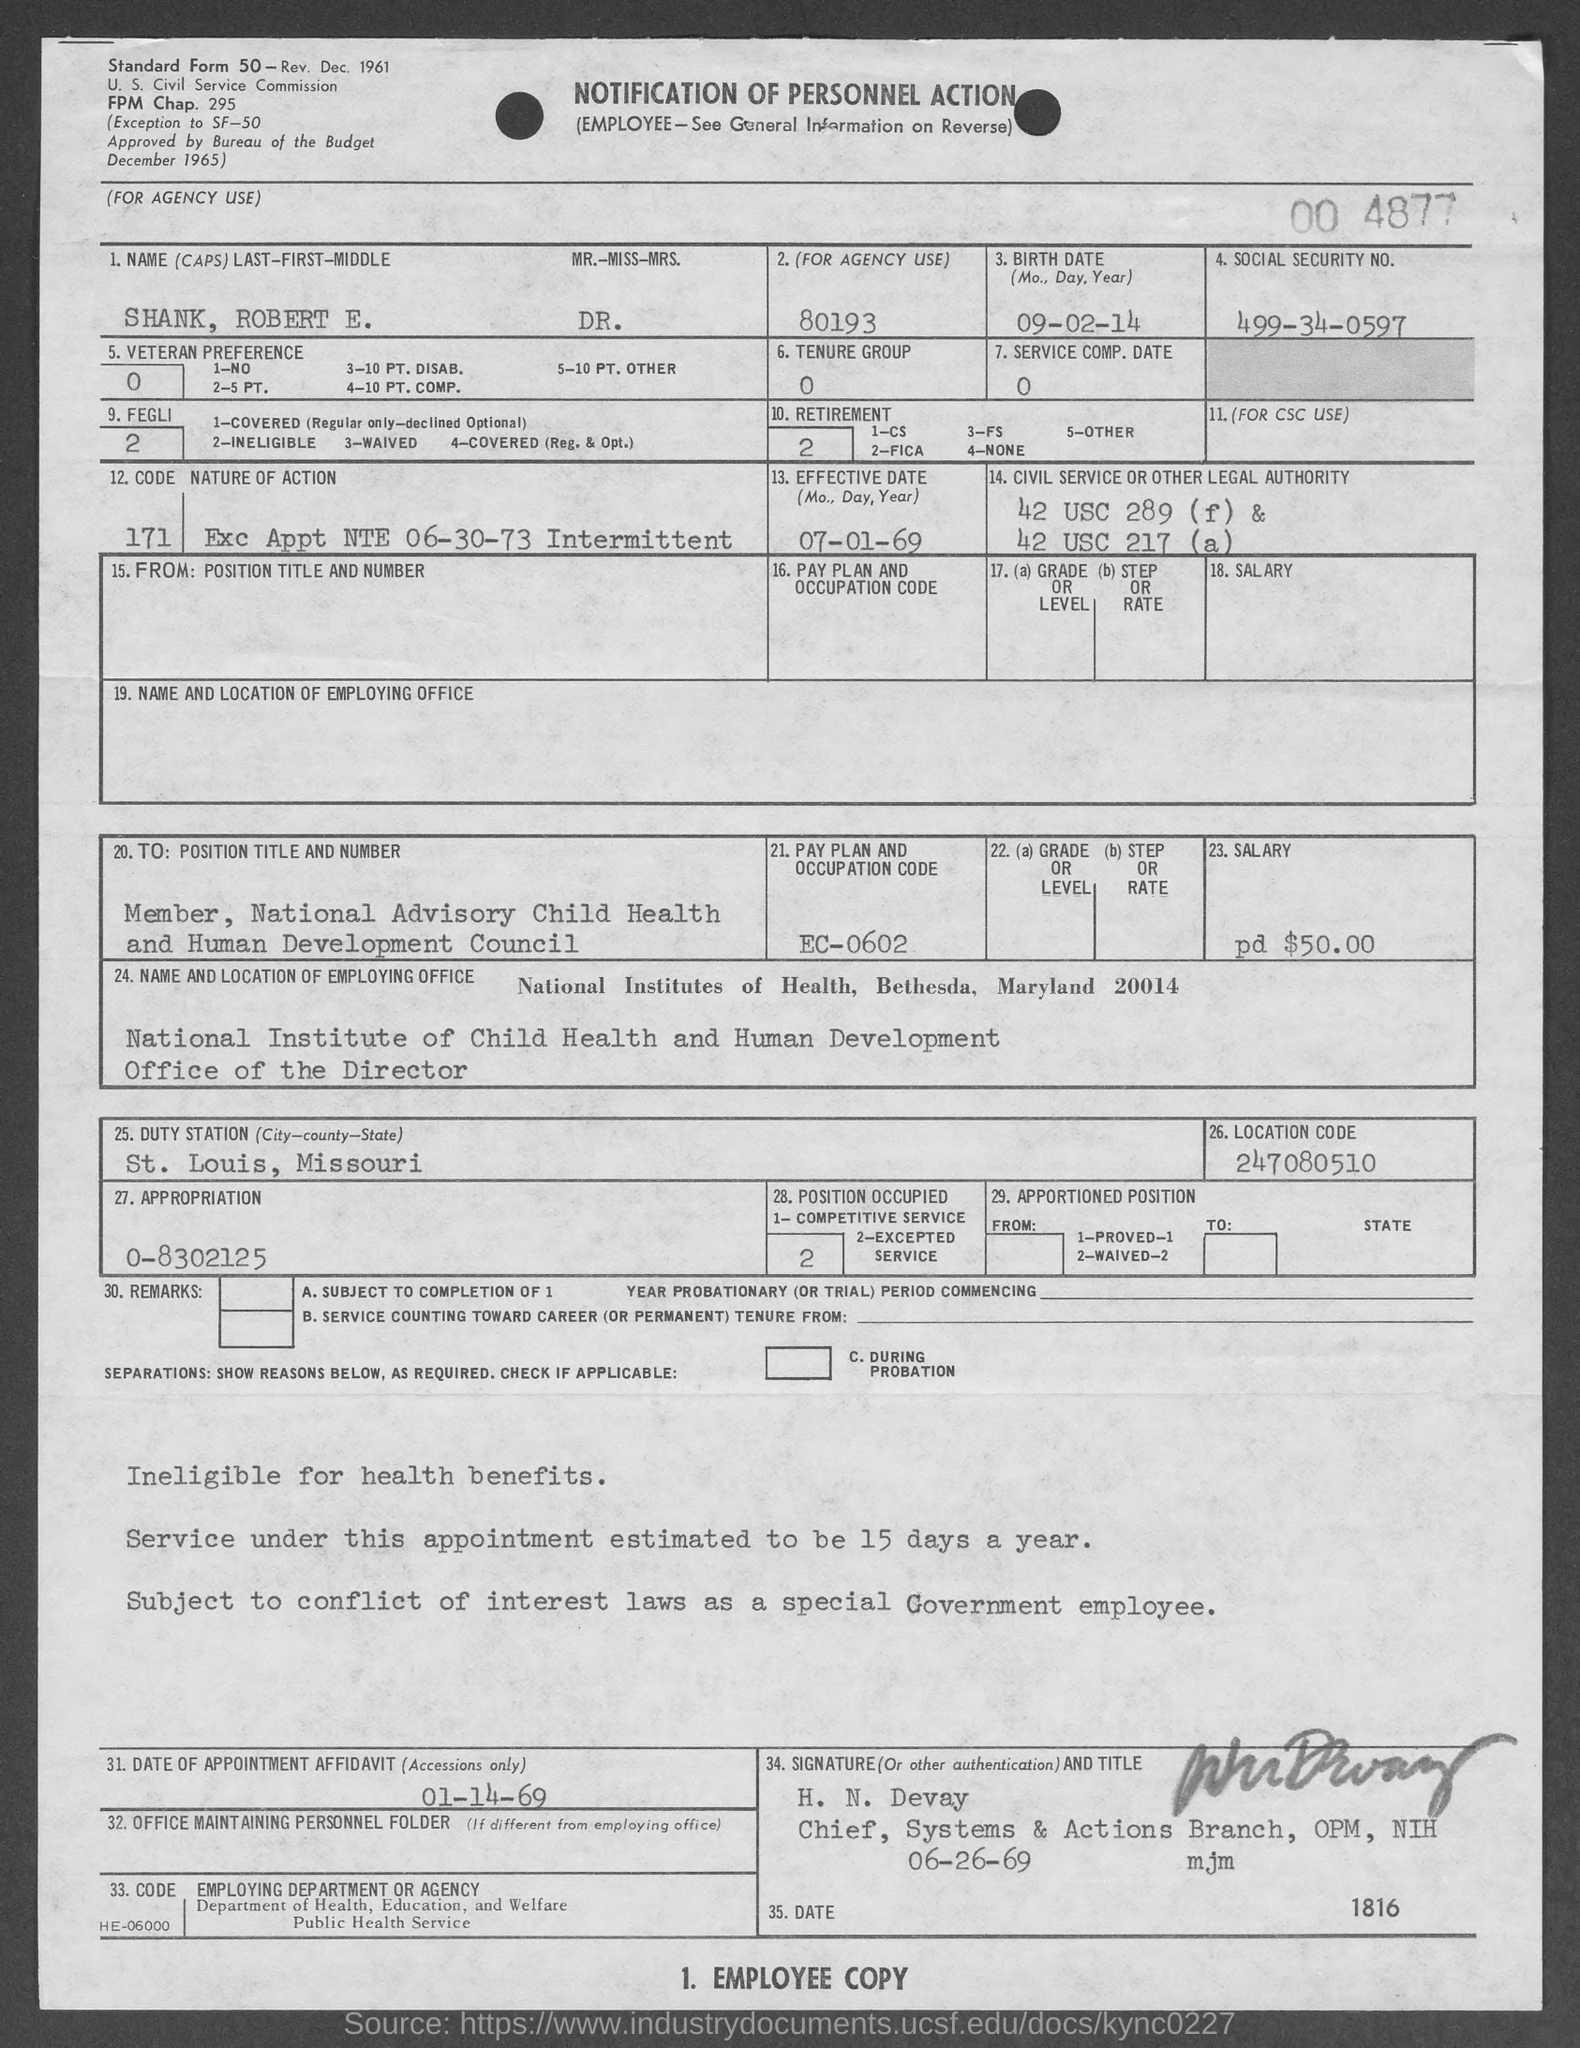Can you tell me what the duties are for the position listed as 'Member, National Advisory Child Health and Human Development Council'? The duties of a 'Member of the National Advisory Child Health and Human Development Council' typically involve advising the agency on policies and strategies related to child health and development. This might include reviewing and recommending research initiatives, programs, and other governmental actions that affect child health services. 